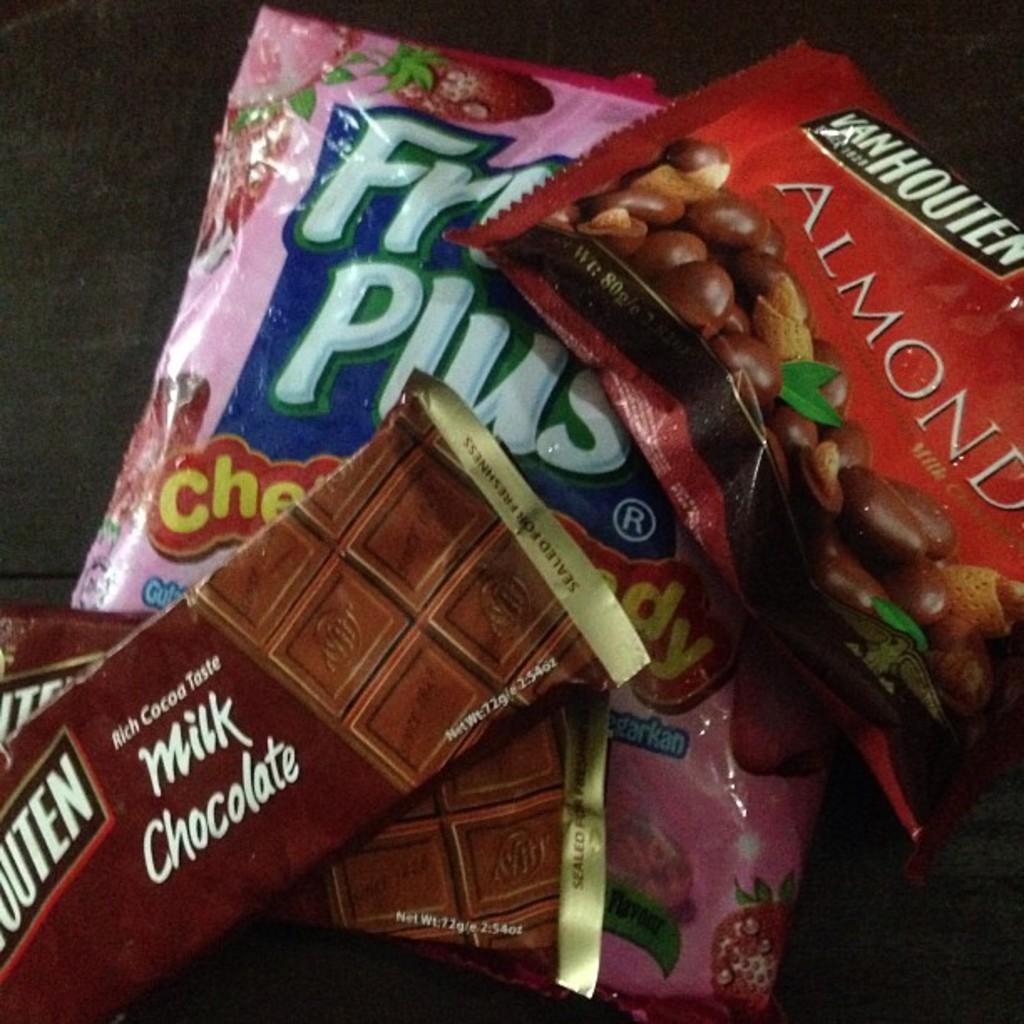Can you describe this image briefly? This image consists of chocolates kept on the floor. 